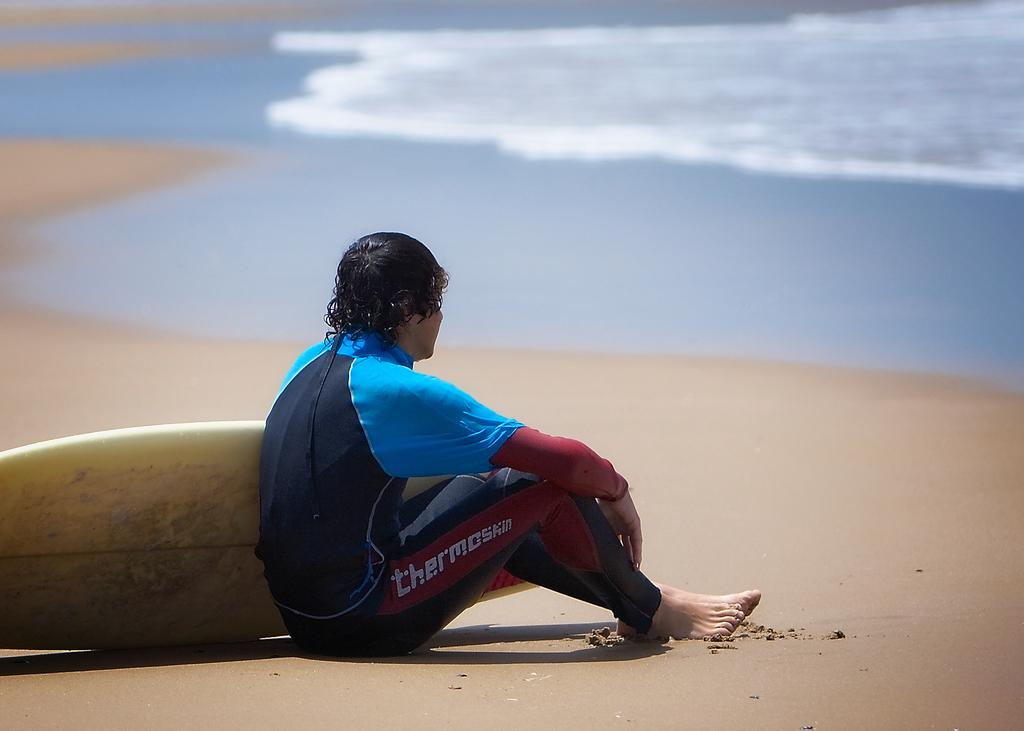What is the person in the image holding? The person in the image is holding a surfboard. Where is the person sitting in the image? The person is sitting on the sand. What can be seen in the background of the image? There is water visible in the background of the image. How many chickens are running around the kettle in the image? There is no kettle or chickens present in the image. What type of self-care activity is the person engaged in while sitting on the sand? The image does not provide information about any self-care activities; it only shows a person with a surfboard sitting on the sand. 